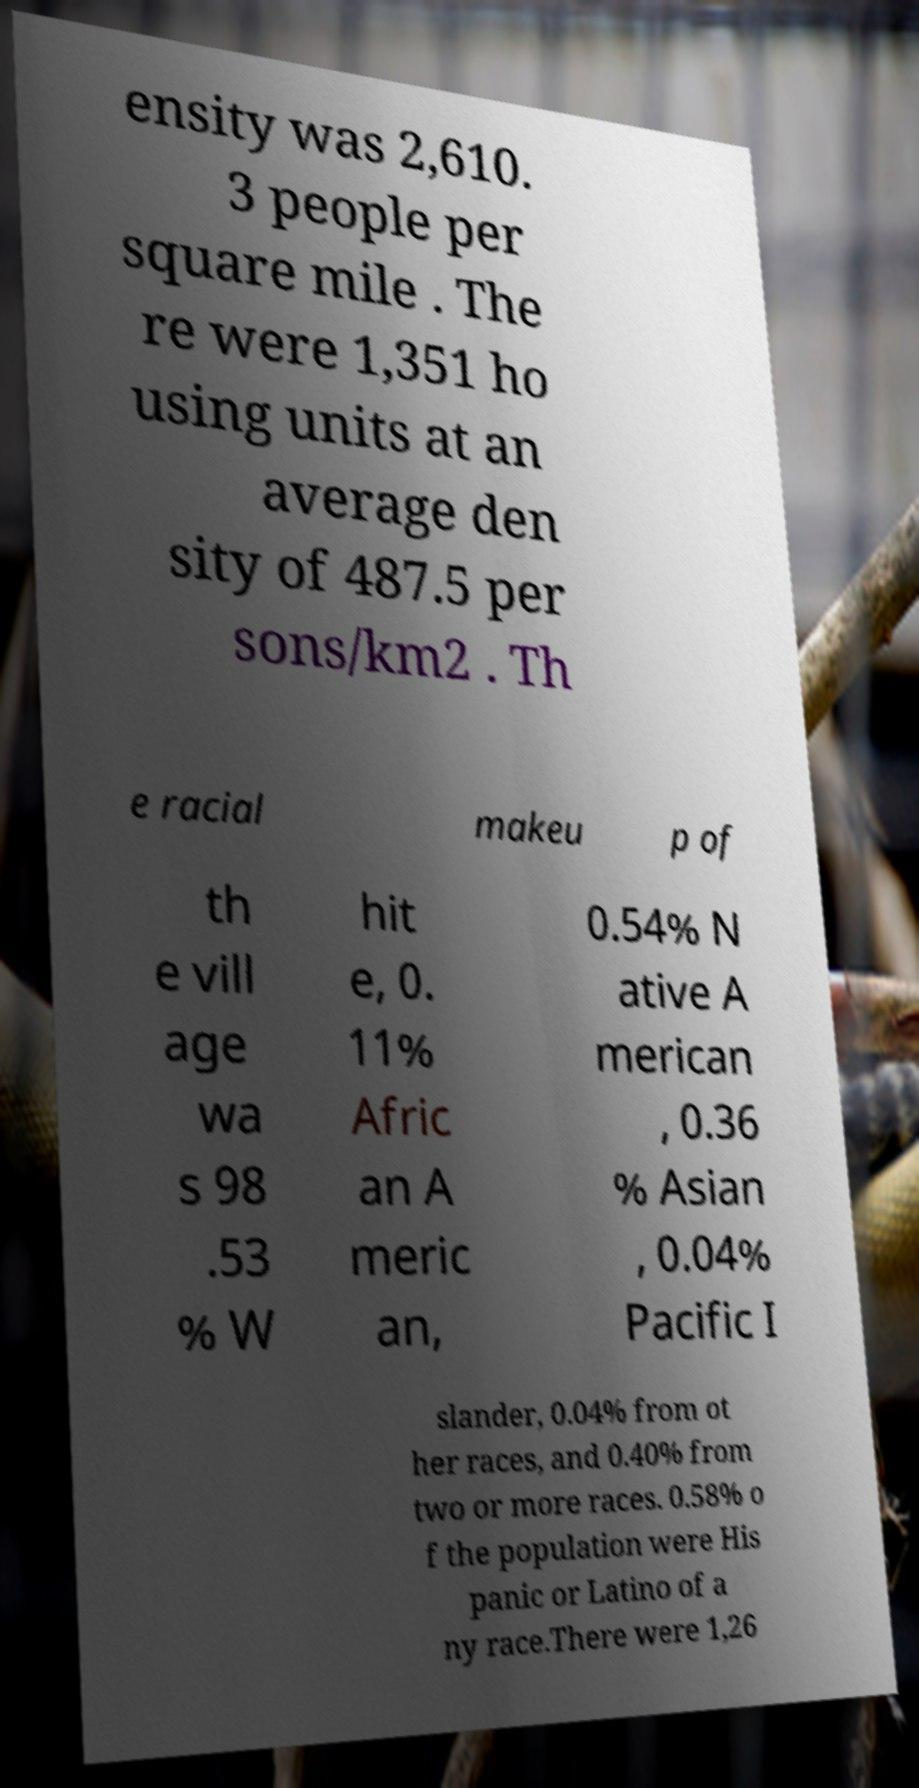Can you accurately transcribe the text from the provided image for me? ensity was 2,610. 3 people per square mile . The re were 1,351 ho using units at an average den sity of 487.5 per sons/km2 . Th e racial makeu p of th e vill age wa s 98 .53 % W hit e, 0. 11% Afric an A meric an, 0.54% N ative A merican , 0.36 % Asian , 0.04% Pacific I slander, 0.04% from ot her races, and 0.40% from two or more races. 0.58% o f the population were His panic or Latino of a ny race.There were 1,26 